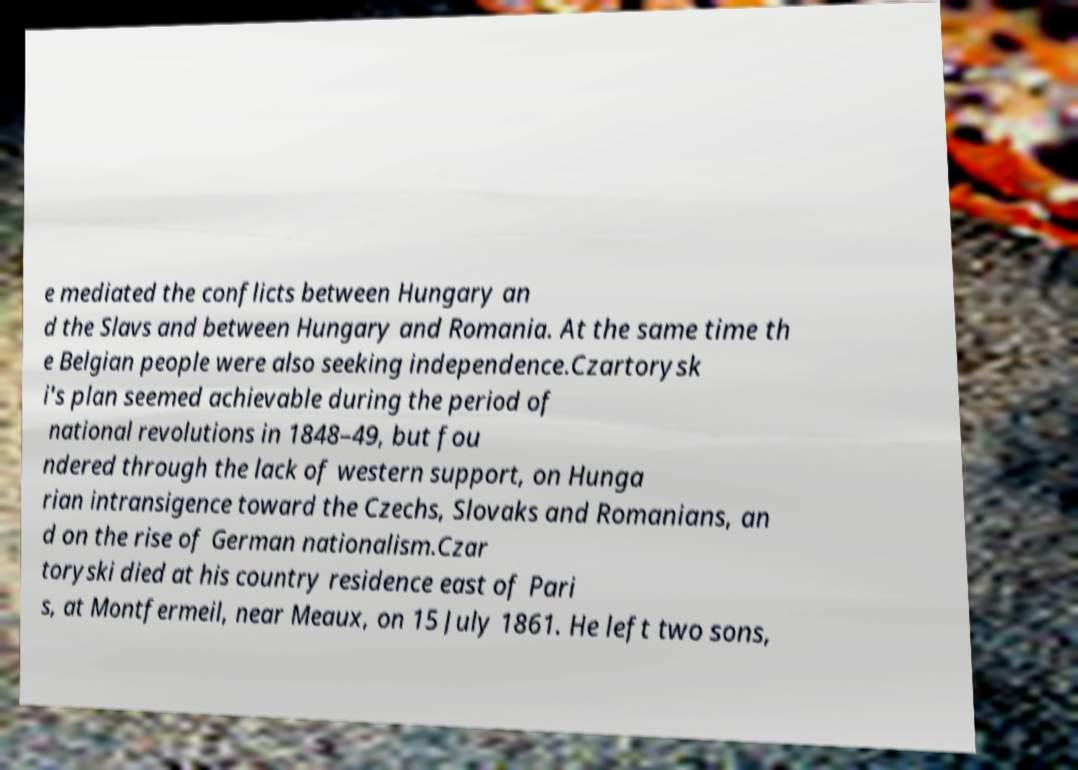Please read and relay the text visible in this image. What does it say? e mediated the conflicts between Hungary an d the Slavs and between Hungary and Romania. At the same time th e Belgian people were also seeking independence.Czartorysk i's plan seemed achievable during the period of national revolutions in 1848–49, but fou ndered through the lack of western support, on Hunga rian intransigence toward the Czechs, Slovaks and Romanians, an d on the rise of German nationalism.Czar toryski died at his country residence east of Pari s, at Montfermeil, near Meaux, on 15 July 1861. He left two sons, 